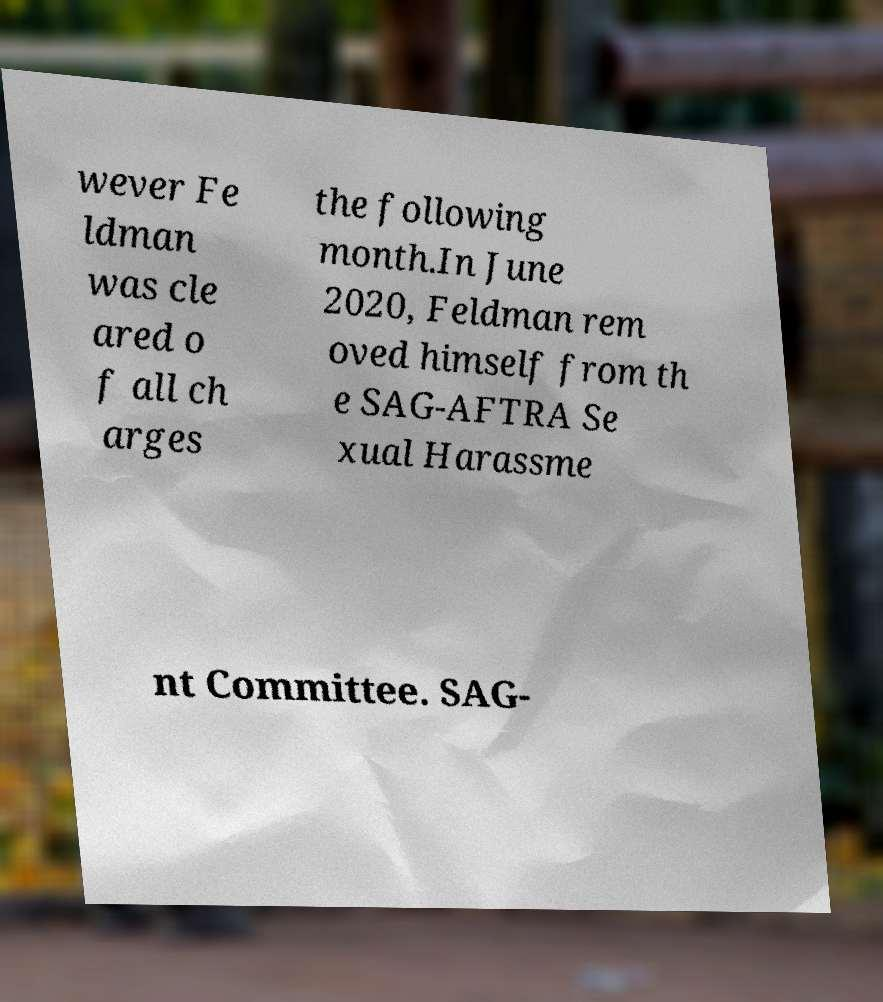Please read and relay the text visible in this image. What does it say? wever Fe ldman was cle ared o f all ch arges the following month.In June 2020, Feldman rem oved himself from th e SAG-AFTRA Se xual Harassme nt Committee. SAG- 